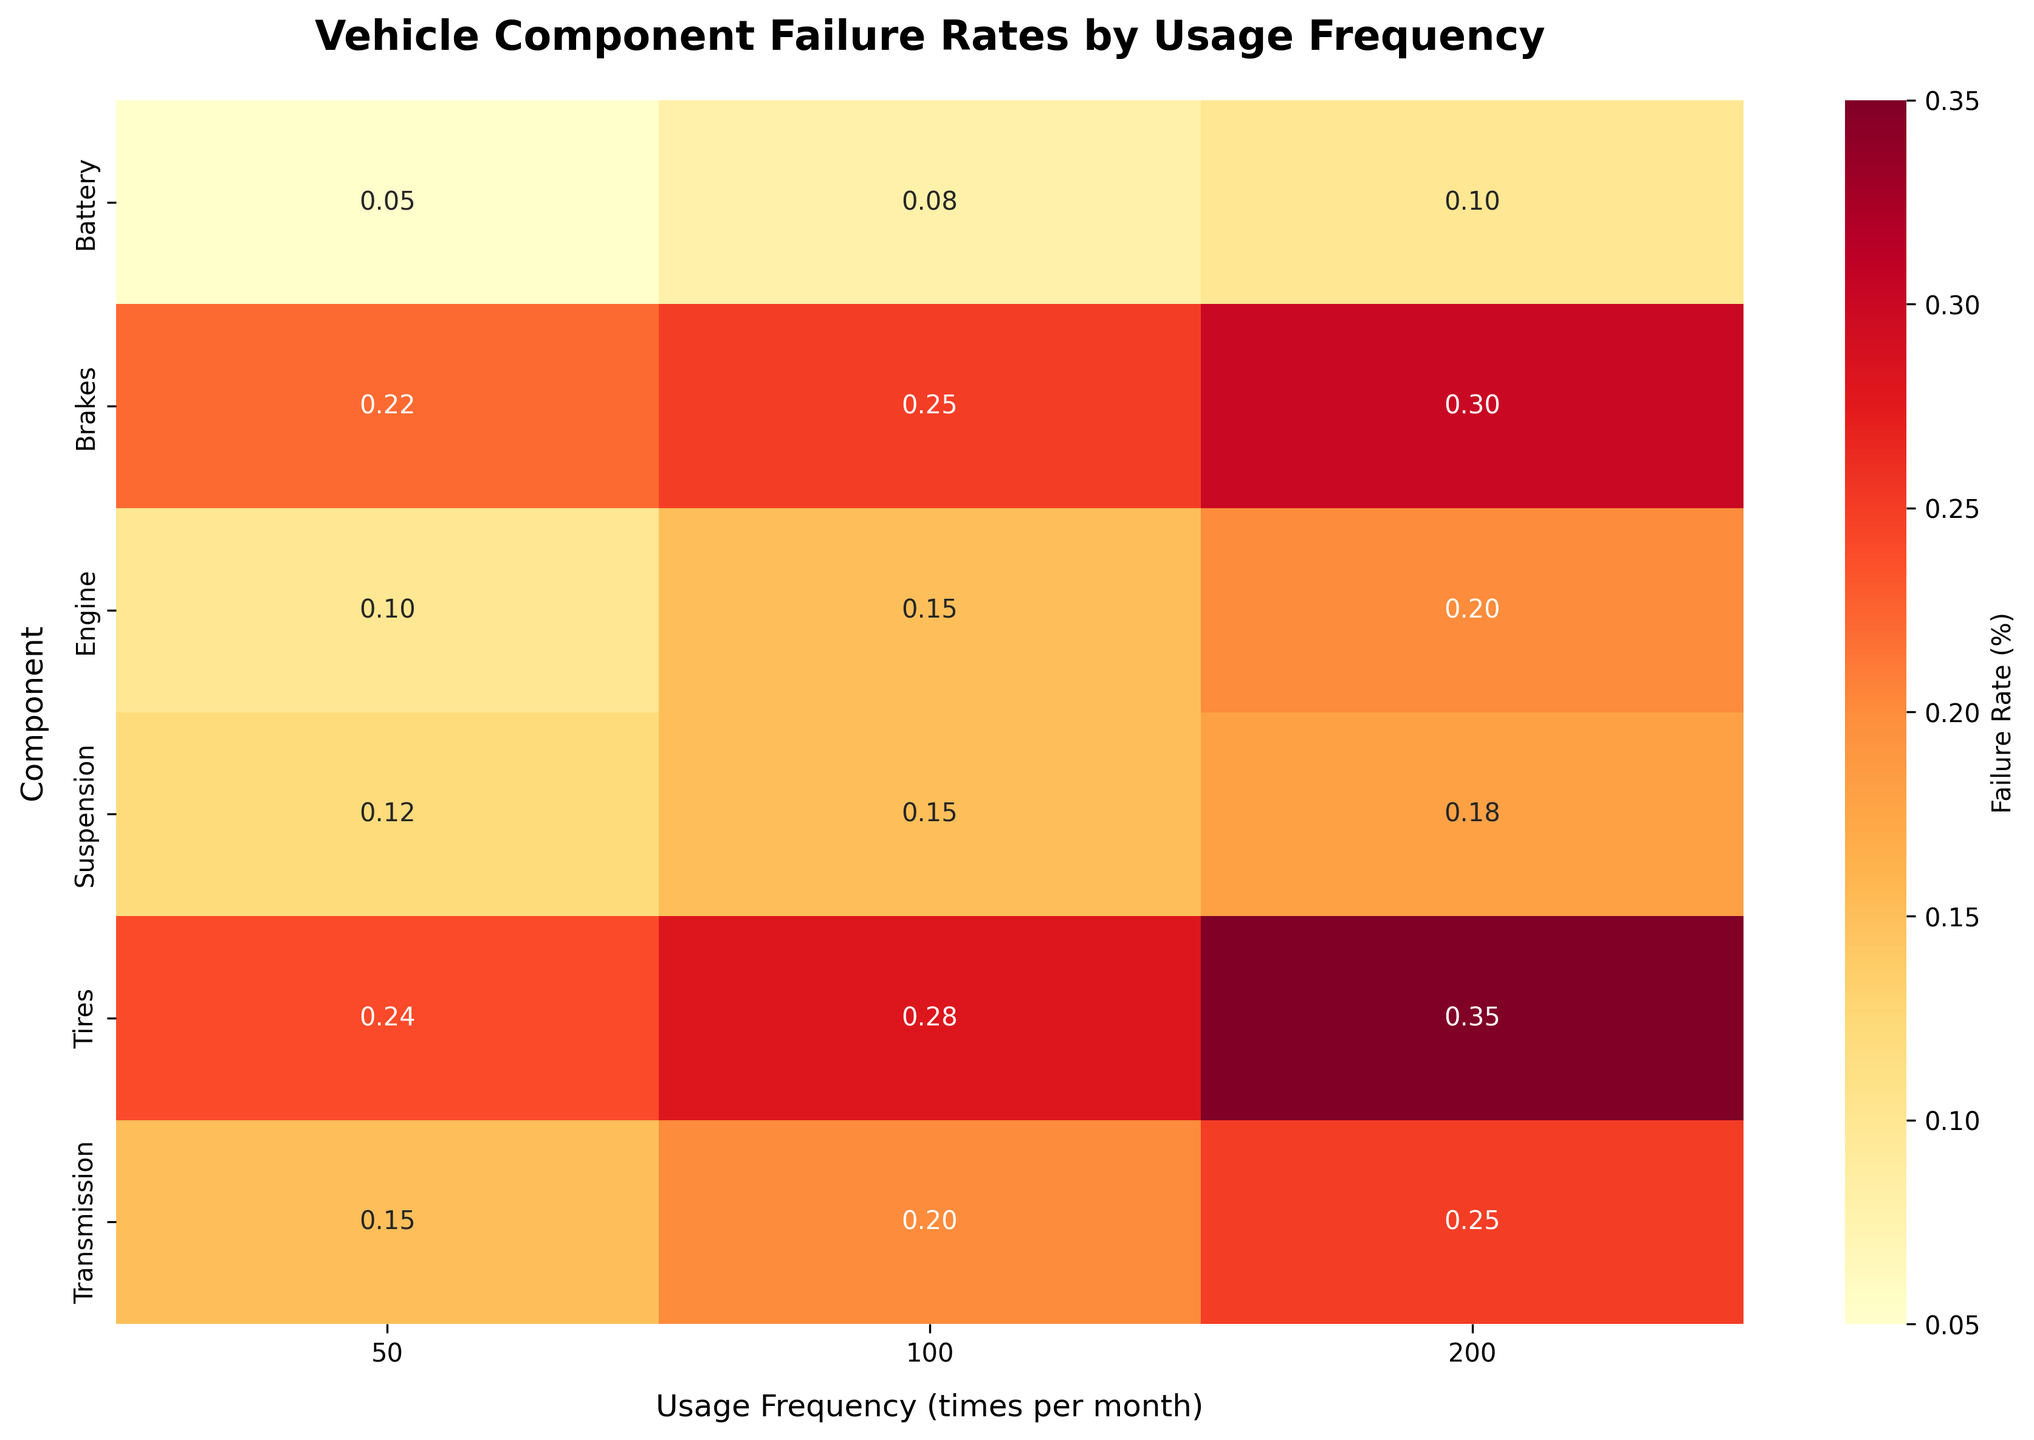What is the title of the heatmap? The title is displayed at the top of the heatmap, which provides a brief description of what the plot represents. In this case, the title reads "Vehicle Component Failure Rates by Usage Frequency".
Answer: Vehicle Component Failure Rates by Usage Frequency Which component has the highest failure rate at 200 times per month of usage frequency? To find the component with the highest failure rate at 200 times per month, look at the column labeled "200" and identify the cell with the highest percentage.
Answer: Tires What is the failure rate of the engine when the usage frequency is 100 times per month? Locate the "Engine" row and then find the cell in the column labeled "100". The failure rate percentage in that cell is the answer.
Answer: 0.15% Among all components, which one shows the lowest failure rate at 50 times per month of usage frequency? Check all the cells under the column labeled "50" and identify the one with the smallest percentage.
Answer: Battery How does the failure rate of brakes change as the usage frequency decreases from 200 to 50 times per month? Look at the row for Brakes and compare the failure rates across the columns labeled "200", "100", and "50".
Answer: The failure rate decreases from 0.3% to 0.25% and then to 0.22% Calculate the average failure rate for the transmission component across all usage frequencies. To find the average, sum all the failure rates for transmission (0.25%, 0.20%, 0.15%) and then divide by the number of data points (3). (0.25 + 0.20 + 0.15) / 3 = 0.20%
Answer: 0.20% Which component has the greatest variation in failure rate across different usage frequencies? Compare the difference between the maximum and minimum failure rates for each component across the columns for 200, 100, and 50 times per month.
Answer: Tires If the usage frequency is fixed at 100 times per month, which component is most likely to fail and which is least likely to fail? Find the maximum and minimum failure rate percentages under the column labeled "100". The component with the maximum percentage is most likely to fail, and the one with the minimum percentage is least likely to fail.
Answer: Most likely: Tires, Least likely: Battery Which component shows a consistent increase in failure rate as usage frequency increases from 50 to 200 times per month? Identify the rows where failure rates continuously increase from the "50" column to the "100" column and then to the "200" column.
Answer: Tires 